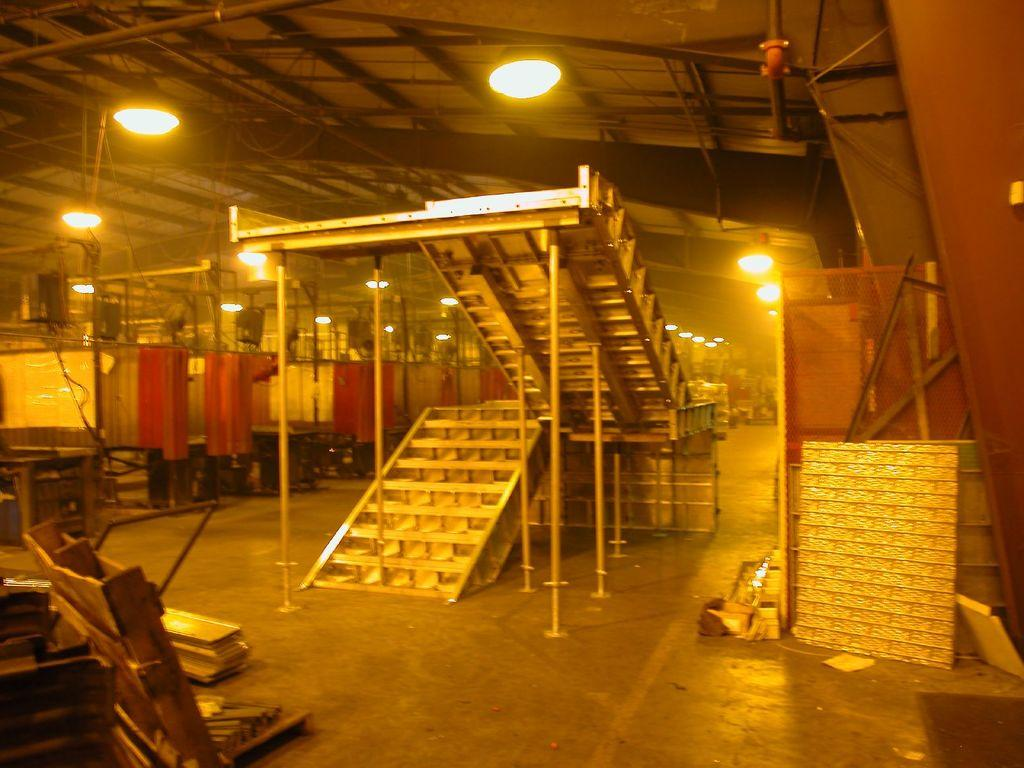What type of structure is in the image? There is a shed in the image. What feature is present inside the shed? The shed contains stairs. What items can be found inside the shed? Sheets and trucks are present in the shed. Can you describe the lighting in the shed? Lights are visible at the top of the shed. Is there a squirrel hiding in the cellar of the shed in the image? There is no cellar mentioned in the facts, and no squirrel is visible in the image. 